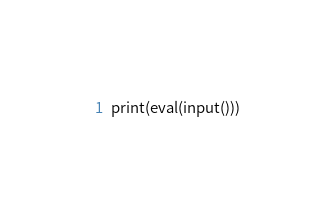<code> <loc_0><loc_0><loc_500><loc_500><_Python_>print(eval(input()))</code> 